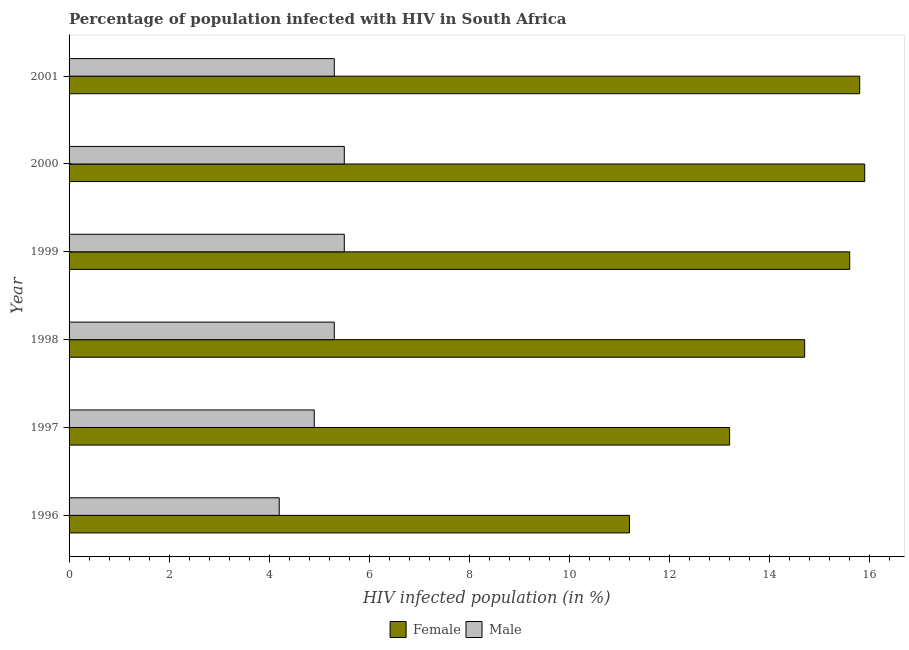How many groups of bars are there?
Give a very brief answer. 6. How many bars are there on the 4th tick from the top?
Offer a very short reply. 2. How many bars are there on the 2nd tick from the bottom?
Offer a very short reply. 2. What is the label of the 2nd group of bars from the top?
Give a very brief answer. 2000. Across all years, what is the maximum percentage of females who are infected with hiv?
Provide a short and direct response. 15.9. What is the total percentage of males who are infected with hiv in the graph?
Ensure brevity in your answer.  30.7. What is the difference between the percentage of females who are infected with hiv in 2000 and the percentage of males who are infected with hiv in 2001?
Make the answer very short. 10.6. In the year 1996, what is the difference between the percentage of females who are infected with hiv and percentage of males who are infected with hiv?
Ensure brevity in your answer.  7. In how many years, is the percentage of females who are infected with hiv greater than 8 %?
Provide a succinct answer. 6. What is the ratio of the percentage of females who are infected with hiv in 2000 to that in 2001?
Your response must be concise. 1.01. Is the percentage of males who are infected with hiv in 1996 less than that in 1998?
Your response must be concise. Yes. What is the difference between the highest and the second highest percentage of males who are infected with hiv?
Your answer should be compact. 0. What is the difference between the highest and the lowest percentage of females who are infected with hiv?
Provide a succinct answer. 4.7. In how many years, is the percentage of males who are infected with hiv greater than the average percentage of males who are infected with hiv taken over all years?
Offer a very short reply. 4. Is the sum of the percentage of females who are infected with hiv in 1997 and 2000 greater than the maximum percentage of males who are infected with hiv across all years?
Offer a very short reply. Yes. What does the 2nd bar from the top in 2000 represents?
Your answer should be compact. Female. How many years are there in the graph?
Keep it short and to the point. 6. Are the values on the major ticks of X-axis written in scientific E-notation?
Ensure brevity in your answer.  No. Does the graph contain grids?
Offer a very short reply. No. Where does the legend appear in the graph?
Your answer should be compact. Bottom center. How are the legend labels stacked?
Give a very brief answer. Horizontal. What is the title of the graph?
Give a very brief answer. Percentage of population infected with HIV in South Africa. What is the label or title of the X-axis?
Make the answer very short. HIV infected population (in %). What is the label or title of the Y-axis?
Your answer should be very brief. Year. What is the HIV infected population (in %) of Female in 1996?
Provide a short and direct response. 11.2. What is the HIV infected population (in %) of Male in 1996?
Your answer should be very brief. 4.2. What is the HIV infected population (in %) in Female in 1998?
Provide a short and direct response. 14.7. What is the HIV infected population (in %) of Male in 1998?
Make the answer very short. 5.3. What is the HIV infected population (in %) of Male in 2001?
Ensure brevity in your answer.  5.3. Across all years, what is the maximum HIV infected population (in %) of Female?
Your answer should be compact. 15.9. Across all years, what is the minimum HIV infected population (in %) of Female?
Provide a succinct answer. 11.2. What is the total HIV infected population (in %) of Female in the graph?
Your answer should be very brief. 86.4. What is the total HIV infected population (in %) of Male in the graph?
Your answer should be very brief. 30.7. What is the difference between the HIV infected population (in %) in Female in 1996 and that in 1997?
Your answer should be very brief. -2. What is the difference between the HIV infected population (in %) of Male in 1996 and that in 1997?
Offer a very short reply. -0.7. What is the difference between the HIV infected population (in %) of Female in 1996 and that in 1998?
Keep it short and to the point. -3.5. What is the difference between the HIV infected population (in %) in Female in 1996 and that in 1999?
Give a very brief answer. -4.4. What is the difference between the HIV infected population (in %) in Female in 1996 and that in 2000?
Make the answer very short. -4.7. What is the difference between the HIV infected population (in %) in Male in 1996 and that in 2000?
Provide a succinct answer. -1.3. What is the difference between the HIV infected population (in %) of Female in 1996 and that in 2001?
Give a very brief answer. -4.6. What is the difference between the HIV infected population (in %) of Male in 1996 and that in 2001?
Give a very brief answer. -1.1. What is the difference between the HIV infected population (in %) in Male in 1997 and that in 1998?
Your response must be concise. -0.4. What is the difference between the HIV infected population (in %) in Female in 1997 and that in 1999?
Offer a very short reply. -2.4. What is the difference between the HIV infected population (in %) in Male in 1997 and that in 1999?
Your response must be concise. -0.6. What is the difference between the HIV infected population (in %) in Male in 1997 and that in 2001?
Provide a short and direct response. -0.4. What is the difference between the HIV infected population (in %) in Male in 1998 and that in 2000?
Keep it short and to the point. -0.2. What is the difference between the HIV infected population (in %) in Female in 1998 and that in 2001?
Your response must be concise. -1.1. What is the difference between the HIV infected population (in %) in Male in 1998 and that in 2001?
Make the answer very short. 0. What is the difference between the HIV infected population (in %) of Female in 1999 and that in 2000?
Your response must be concise. -0.3. What is the difference between the HIV infected population (in %) in Male in 1999 and that in 2000?
Give a very brief answer. 0. What is the difference between the HIV infected population (in %) in Female in 1996 and the HIV infected population (in %) in Male in 1997?
Provide a short and direct response. 6.3. What is the difference between the HIV infected population (in %) in Female in 1996 and the HIV infected population (in %) in Male in 1998?
Offer a very short reply. 5.9. What is the difference between the HIV infected population (in %) in Female in 1996 and the HIV infected population (in %) in Male in 1999?
Your answer should be very brief. 5.7. What is the difference between the HIV infected population (in %) in Female in 1996 and the HIV infected population (in %) in Male in 2000?
Offer a very short reply. 5.7. What is the difference between the HIV infected population (in %) of Female in 1997 and the HIV infected population (in %) of Male in 1999?
Ensure brevity in your answer.  7.7. What is the difference between the HIV infected population (in %) of Female in 1998 and the HIV infected population (in %) of Male in 1999?
Your response must be concise. 9.2. What is the difference between the HIV infected population (in %) of Female in 1998 and the HIV infected population (in %) of Male in 2000?
Provide a short and direct response. 9.2. What is the difference between the HIV infected population (in %) in Female in 1998 and the HIV infected population (in %) in Male in 2001?
Provide a short and direct response. 9.4. What is the difference between the HIV infected population (in %) in Female in 1999 and the HIV infected population (in %) in Male in 2001?
Offer a terse response. 10.3. What is the average HIV infected population (in %) in Male per year?
Your answer should be very brief. 5.12. In the year 1997, what is the difference between the HIV infected population (in %) in Female and HIV infected population (in %) in Male?
Your answer should be very brief. 8.3. In the year 1998, what is the difference between the HIV infected population (in %) of Female and HIV infected population (in %) of Male?
Your answer should be compact. 9.4. In the year 2000, what is the difference between the HIV infected population (in %) in Female and HIV infected population (in %) in Male?
Give a very brief answer. 10.4. In the year 2001, what is the difference between the HIV infected population (in %) of Female and HIV infected population (in %) of Male?
Offer a very short reply. 10.5. What is the ratio of the HIV infected population (in %) of Female in 1996 to that in 1997?
Give a very brief answer. 0.85. What is the ratio of the HIV infected population (in %) of Male in 1996 to that in 1997?
Ensure brevity in your answer.  0.86. What is the ratio of the HIV infected population (in %) in Female in 1996 to that in 1998?
Your answer should be compact. 0.76. What is the ratio of the HIV infected population (in %) of Male in 1996 to that in 1998?
Provide a short and direct response. 0.79. What is the ratio of the HIV infected population (in %) of Female in 1996 to that in 1999?
Your answer should be very brief. 0.72. What is the ratio of the HIV infected population (in %) in Male in 1996 to that in 1999?
Provide a succinct answer. 0.76. What is the ratio of the HIV infected population (in %) in Female in 1996 to that in 2000?
Offer a very short reply. 0.7. What is the ratio of the HIV infected population (in %) in Male in 1996 to that in 2000?
Provide a short and direct response. 0.76. What is the ratio of the HIV infected population (in %) in Female in 1996 to that in 2001?
Provide a short and direct response. 0.71. What is the ratio of the HIV infected population (in %) in Male in 1996 to that in 2001?
Offer a very short reply. 0.79. What is the ratio of the HIV infected population (in %) of Female in 1997 to that in 1998?
Your answer should be very brief. 0.9. What is the ratio of the HIV infected population (in %) in Male in 1997 to that in 1998?
Keep it short and to the point. 0.92. What is the ratio of the HIV infected population (in %) of Female in 1997 to that in 1999?
Ensure brevity in your answer.  0.85. What is the ratio of the HIV infected population (in %) in Male in 1997 to that in 1999?
Provide a succinct answer. 0.89. What is the ratio of the HIV infected population (in %) in Female in 1997 to that in 2000?
Your answer should be very brief. 0.83. What is the ratio of the HIV infected population (in %) in Male in 1997 to that in 2000?
Make the answer very short. 0.89. What is the ratio of the HIV infected population (in %) of Female in 1997 to that in 2001?
Your response must be concise. 0.84. What is the ratio of the HIV infected population (in %) in Male in 1997 to that in 2001?
Provide a short and direct response. 0.92. What is the ratio of the HIV infected population (in %) of Female in 1998 to that in 1999?
Make the answer very short. 0.94. What is the ratio of the HIV infected population (in %) in Male in 1998 to that in 1999?
Provide a succinct answer. 0.96. What is the ratio of the HIV infected population (in %) of Female in 1998 to that in 2000?
Offer a very short reply. 0.92. What is the ratio of the HIV infected population (in %) of Male in 1998 to that in 2000?
Keep it short and to the point. 0.96. What is the ratio of the HIV infected population (in %) in Female in 1998 to that in 2001?
Keep it short and to the point. 0.93. What is the ratio of the HIV infected population (in %) in Female in 1999 to that in 2000?
Make the answer very short. 0.98. What is the ratio of the HIV infected population (in %) in Female in 1999 to that in 2001?
Make the answer very short. 0.99. What is the ratio of the HIV infected population (in %) of Male in 1999 to that in 2001?
Offer a terse response. 1.04. What is the ratio of the HIV infected population (in %) in Male in 2000 to that in 2001?
Your answer should be compact. 1.04. What is the difference between the highest and the second highest HIV infected population (in %) in Female?
Give a very brief answer. 0.1. What is the difference between the highest and the second highest HIV infected population (in %) in Male?
Your response must be concise. 0. What is the difference between the highest and the lowest HIV infected population (in %) in Female?
Offer a very short reply. 4.7. What is the difference between the highest and the lowest HIV infected population (in %) in Male?
Provide a short and direct response. 1.3. 